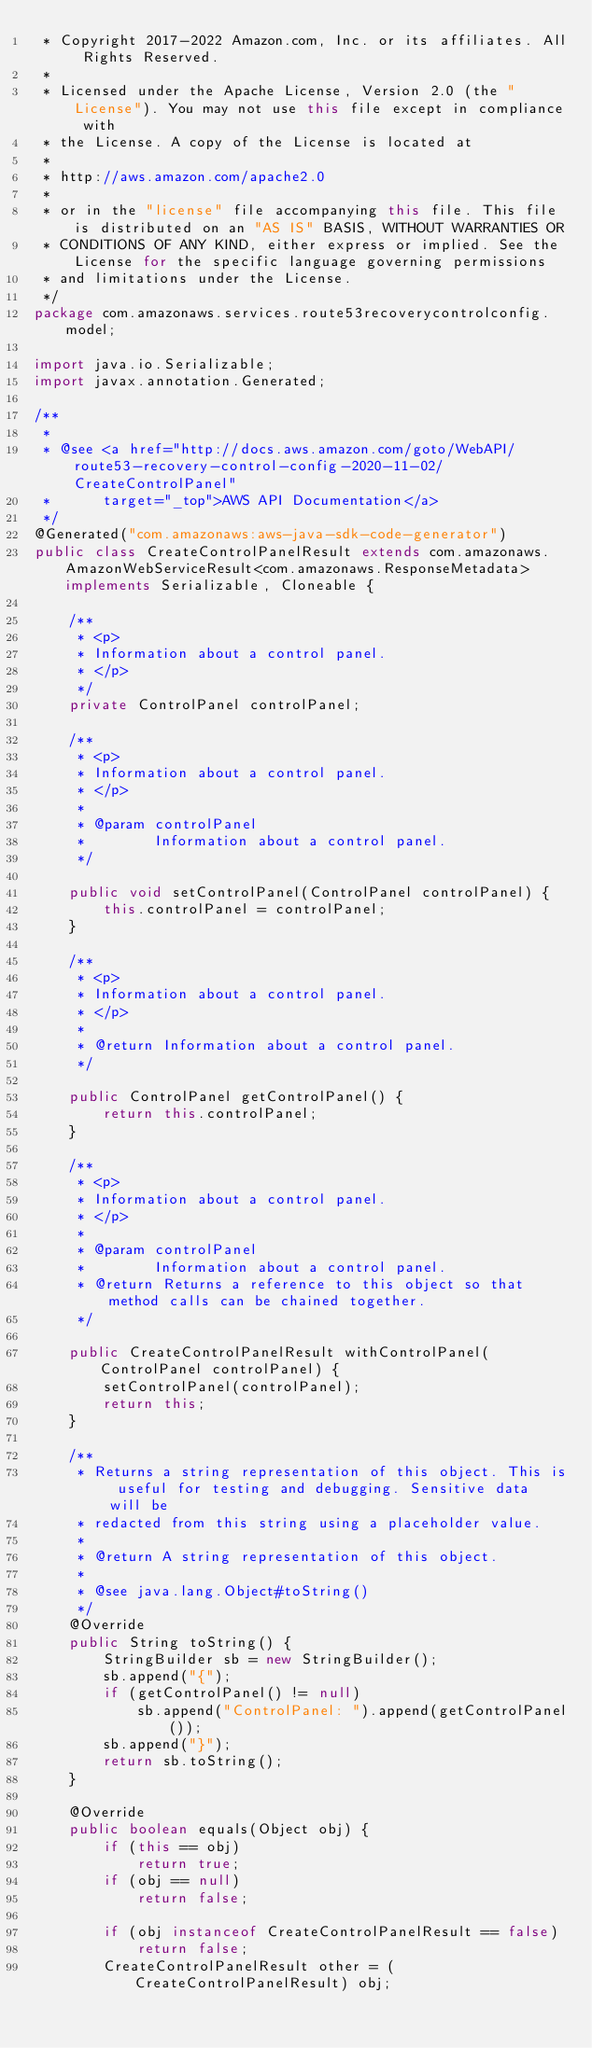<code> <loc_0><loc_0><loc_500><loc_500><_Java_> * Copyright 2017-2022 Amazon.com, Inc. or its affiliates. All Rights Reserved.
 * 
 * Licensed under the Apache License, Version 2.0 (the "License"). You may not use this file except in compliance with
 * the License. A copy of the License is located at
 * 
 * http://aws.amazon.com/apache2.0
 * 
 * or in the "license" file accompanying this file. This file is distributed on an "AS IS" BASIS, WITHOUT WARRANTIES OR
 * CONDITIONS OF ANY KIND, either express or implied. See the License for the specific language governing permissions
 * and limitations under the License.
 */
package com.amazonaws.services.route53recoverycontrolconfig.model;

import java.io.Serializable;
import javax.annotation.Generated;

/**
 * 
 * @see <a href="http://docs.aws.amazon.com/goto/WebAPI/route53-recovery-control-config-2020-11-02/CreateControlPanel"
 *      target="_top">AWS API Documentation</a>
 */
@Generated("com.amazonaws:aws-java-sdk-code-generator")
public class CreateControlPanelResult extends com.amazonaws.AmazonWebServiceResult<com.amazonaws.ResponseMetadata> implements Serializable, Cloneable {

    /**
     * <p>
     * Information about a control panel.
     * </p>
     */
    private ControlPanel controlPanel;

    /**
     * <p>
     * Information about a control panel.
     * </p>
     * 
     * @param controlPanel
     *        Information about a control panel.
     */

    public void setControlPanel(ControlPanel controlPanel) {
        this.controlPanel = controlPanel;
    }

    /**
     * <p>
     * Information about a control panel.
     * </p>
     * 
     * @return Information about a control panel.
     */

    public ControlPanel getControlPanel() {
        return this.controlPanel;
    }

    /**
     * <p>
     * Information about a control panel.
     * </p>
     * 
     * @param controlPanel
     *        Information about a control panel.
     * @return Returns a reference to this object so that method calls can be chained together.
     */

    public CreateControlPanelResult withControlPanel(ControlPanel controlPanel) {
        setControlPanel(controlPanel);
        return this;
    }

    /**
     * Returns a string representation of this object. This is useful for testing and debugging. Sensitive data will be
     * redacted from this string using a placeholder value.
     *
     * @return A string representation of this object.
     *
     * @see java.lang.Object#toString()
     */
    @Override
    public String toString() {
        StringBuilder sb = new StringBuilder();
        sb.append("{");
        if (getControlPanel() != null)
            sb.append("ControlPanel: ").append(getControlPanel());
        sb.append("}");
        return sb.toString();
    }

    @Override
    public boolean equals(Object obj) {
        if (this == obj)
            return true;
        if (obj == null)
            return false;

        if (obj instanceof CreateControlPanelResult == false)
            return false;
        CreateControlPanelResult other = (CreateControlPanelResult) obj;</code> 